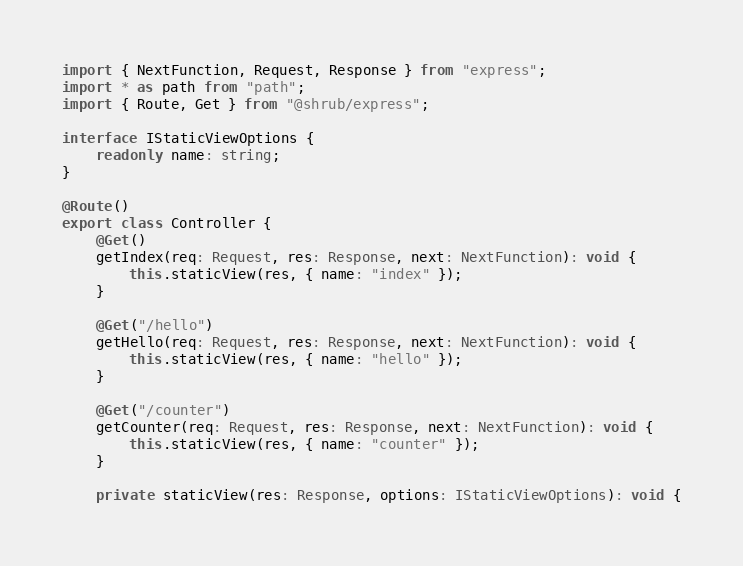Convert code to text. <code><loc_0><loc_0><loc_500><loc_500><_TypeScript_>import { NextFunction, Request, Response } from "express";
import * as path from "path";
import { Route, Get } from "@shrub/express";

interface IStaticViewOptions {
    readonly name: string;
}

@Route()
export class Controller {
    @Get()
    getIndex(req: Request, res: Response, next: NextFunction): void {
        this.staticView(res, { name: "index" });
    }

    @Get("/hello")
    getHello(req: Request, res: Response, next: NextFunction): void {
        this.staticView(res, { name: "hello" });
    }

    @Get("/counter")
    getCounter(req: Request, res: Response, next: NextFunction): void {
        this.staticView(res, { name: "counter" });
    }

    private staticView(res: Response, options: IStaticViewOptions): void {</code> 